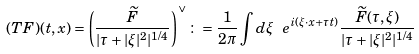Convert formula to latex. <formula><loc_0><loc_0><loc_500><loc_500>( T F ) ( t , x ) = \left ( \frac { \widetilde { F } } { | \tau + | \xi | ^ { 2 } | ^ { 1 / 4 } } \right ) ^ { \vee } \colon = \frac { 1 } { 2 \pi } \int d \xi \ e ^ { i ( \xi \cdot x + \tau t ) } \frac { \widetilde { F } ( \tau , \xi ) } { | \tau + | \xi | ^ { 2 } | ^ { 1 / 4 } }</formula> 